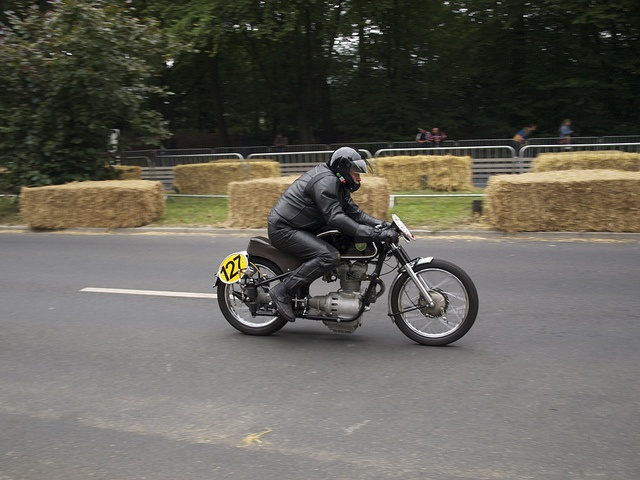Describe the objects in this image and their specific colors. I can see motorcycle in black, gray, and lightgray tones, people in black, gray, and darkgray tones, people in black, gray, and maroon tones, people in black, maroon, gray, and brown tones, and people in black, gray, and maroon tones in this image. 